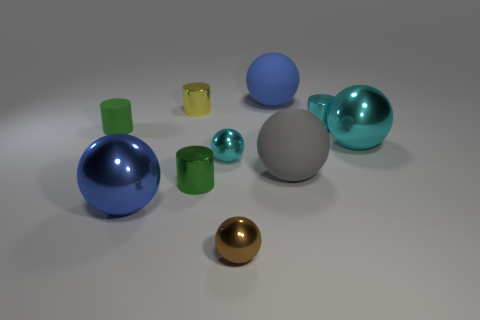Is there any other thing of the same color as the tiny matte cylinder?
Keep it short and to the point. Yes. There is a metallic cylinder in front of the small cyan metallic cylinder; is its color the same as the tiny rubber thing?
Ensure brevity in your answer.  Yes. What shape is the thing that is the same color as the tiny rubber cylinder?
Your answer should be very brief. Cylinder. What shape is the gray rubber object?
Provide a short and direct response. Sphere. What number of things are cyan objects left of the blue rubber object or rubber objects?
Provide a short and direct response. 4. The green thing that is made of the same material as the tiny yellow cylinder is what size?
Offer a very short reply. Small. Is the number of objects left of the big blue rubber object greater than the number of large gray matte things?
Offer a terse response. Yes. There is a blue metallic object; does it have the same shape as the small green thing in front of the gray rubber ball?
Give a very brief answer. No. What number of small things are either green things or gray things?
Make the answer very short. 2. There is a cylinder that is the same color as the small rubber object; what is its size?
Provide a short and direct response. Small. 